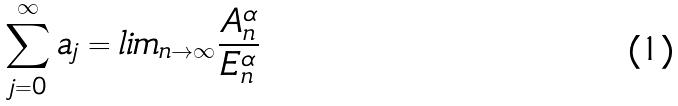Convert formula to latex. <formula><loc_0><loc_0><loc_500><loc_500>\sum _ { j = 0 } ^ { \infty } a _ { j } = l i m _ { n \rightarrow \infty } \frac { A _ { n } ^ { \alpha } } { E _ { n } ^ { \alpha } }</formula> 